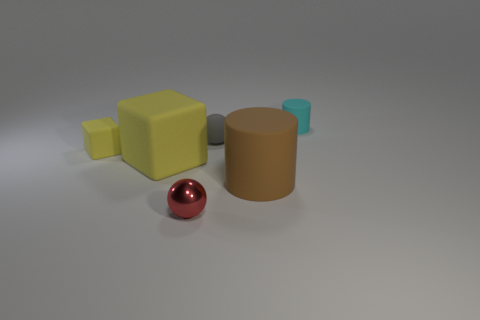Add 2 cubes. How many objects exist? 8 Subtract 1 balls. How many balls are left? 1 Subtract all spheres. How many objects are left? 4 Subtract all blue cylinders. Subtract all purple cubes. How many cylinders are left? 2 Subtract all green cubes. How many cyan cylinders are left? 1 Add 6 tiny gray rubber things. How many tiny gray rubber things are left? 7 Add 5 big red things. How many big red things exist? 5 Subtract 0 blue cylinders. How many objects are left? 6 Subtract all blue rubber cubes. Subtract all tiny objects. How many objects are left? 2 